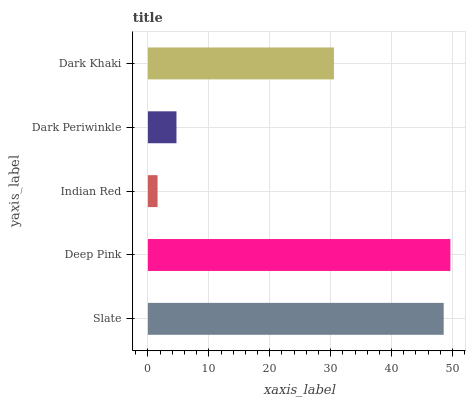Is Indian Red the minimum?
Answer yes or no. Yes. Is Deep Pink the maximum?
Answer yes or no. Yes. Is Deep Pink the minimum?
Answer yes or no. No. Is Indian Red the maximum?
Answer yes or no. No. Is Deep Pink greater than Indian Red?
Answer yes or no. Yes. Is Indian Red less than Deep Pink?
Answer yes or no. Yes. Is Indian Red greater than Deep Pink?
Answer yes or no. No. Is Deep Pink less than Indian Red?
Answer yes or no. No. Is Dark Khaki the high median?
Answer yes or no. Yes. Is Dark Khaki the low median?
Answer yes or no. Yes. Is Indian Red the high median?
Answer yes or no. No. Is Dark Periwinkle the low median?
Answer yes or no. No. 